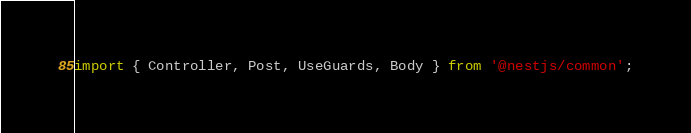<code> <loc_0><loc_0><loc_500><loc_500><_TypeScript_>import { Controller, Post, UseGuards, Body } from '@nestjs/common';</code> 